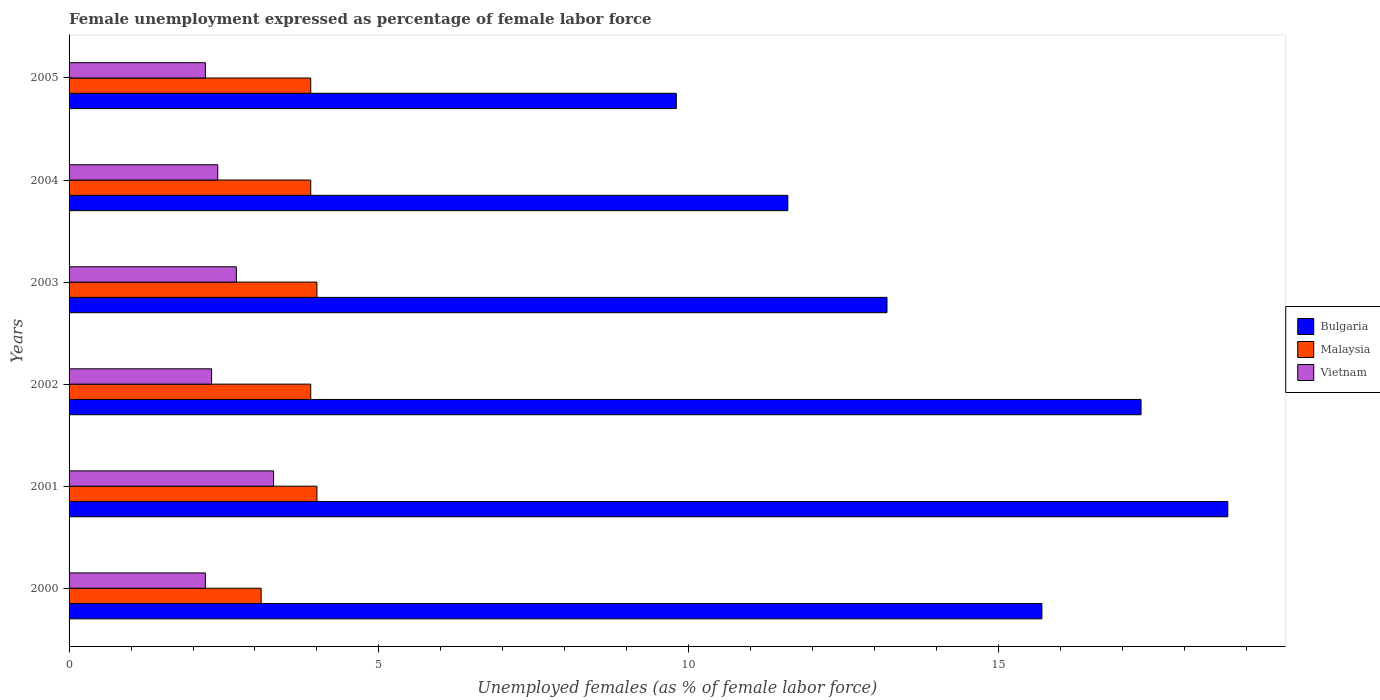How many different coloured bars are there?
Offer a terse response. 3. How many groups of bars are there?
Keep it short and to the point. 6. How many bars are there on the 4th tick from the top?
Provide a short and direct response. 3. What is the label of the 3rd group of bars from the top?
Provide a short and direct response. 2003. In how many cases, is the number of bars for a given year not equal to the number of legend labels?
Your answer should be compact. 0. Across all years, what is the maximum unemployment in females in in Bulgaria?
Your response must be concise. 18.7. Across all years, what is the minimum unemployment in females in in Malaysia?
Ensure brevity in your answer.  3.1. In which year was the unemployment in females in in Bulgaria maximum?
Make the answer very short. 2001. What is the total unemployment in females in in Malaysia in the graph?
Ensure brevity in your answer.  22.8. What is the difference between the unemployment in females in in Bulgaria in 2003 and that in 2004?
Provide a succinct answer. 1.6. What is the difference between the unemployment in females in in Vietnam in 2003 and the unemployment in females in in Malaysia in 2002?
Offer a terse response. -1.2. What is the average unemployment in females in in Malaysia per year?
Offer a terse response. 3.8. In the year 2005, what is the difference between the unemployment in females in in Malaysia and unemployment in females in in Bulgaria?
Give a very brief answer. -5.9. What is the ratio of the unemployment in females in in Malaysia in 2000 to that in 2002?
Your response must be concise. 0.79. Is the difference between the unemployment in females in in Malaysia in 2002 and 2003 greater than the difference between the unemployment in females in in Bulgaria in 2002 and 2003?
Your response must be concise. No. What is the difference between the highest and the second highest unemployment in females in in Bulgaria?
Ensure brevity in your answer.  1.4. What is the difference between the highest and the lowest unemployment in females in in Vietnam?
Your answer should be very brief. 1.1. In how many years, is the unemployment in females in in Malaysia greater than the average unemployment in females in in Malaysia taken over all years?
Offer a very short reply. 5. What does the 3rd bar from the top in 2003 represents?
Your answer should be compact. Bulgaria. What does the 2nd bar from the bottom in 2005 represents?
Offer a very short reply. Malaysia. Is it the case that in every year, the sum of the unemployment in females in in Bulgaria and unemployment in females in in Vietnam is greater than the unemployment in females in in Malaysia?
Your answer should be compact. Yes. Are all the bars in the graph horizontal?
Offer a terse response. Yes. How many years are there in the graph?
Your response must be concise. 6. What is the difference between two consecutive major ticks on the X-axis?
Provide a short and direct response. 5. Does the graph contain any zero values?
Make the answer very short. No. Where does the legend appear in the graph?
Offer a terse response. Center right. How are the legend labels stacked?
Give a very brief answer. Vertical. What is the title of the graph?
Give a very brief answer. Female unemployment expressed as percentage of female labor force. What is the label or title of the X-axis?
Your answer should be very brief. Unemployed females (as % of female labor force). What is the Unemployed females (as % of female labor force) in Bulgaria in 2000?
Give a very brief answer. 15.7. What is the Unemployed females (as % of female labor force) of Malaysia in 2000?
Your answer should be very brief. 3.1. What is the Unemployed females (as % of female labor force) of Vietnam in 2000?
Offer a terse response. 2.2. What is the Unemployed females (as % of female labor force) in Bulgaria in 2001?
Ensure brevity in your answer.  18.7. What is the Unemployed females (as % of female labor force) in Malaysia in 2001?
Keep it short and to the point. 4. What is the Unemployed females (as % of female labor force) of Vietnam in 2001?
Your answer should be compact. 3.3. What is the Unemployed females (as % of female labor force) of Bulgaria in 2002?
Make the answer very short. 17.3. What is the Unemployed females (as % of female labor force) in Malaysia in 2002?
Give a very brief answer. 3.9. What is the Unemployed females (as % of female labor force) of Vietnam in 2002?
Your answer should be compact. 2.3. What is the Unemployed females (as % of female labor force) in Bulgaria in 2003?
Keep it short and to the point. 13.2. What is the Unemployed females (as % of female labor force) of Vietnam in 2003?
Keep it short and to the point. 2.7. What is the Unemployed females (as % of female labor force) of Bulgaria in 2004?
Offer a terse response. 11.6. What is the Unemployed females (as % of female labor force) in Malaysia in 2004?
Your answer should be compact. 3.9. What is the Unemployed females (as % of female labor force) of Vietnam in 2004?
Give a very brief answer. 2.4. What is the Unemployed females (as % of female labor force) of Bulgaria in 2005?
Your answer should be compact. 9.8. What is the Unemployed females (as % of female labor force) of Malaysia in 2005?
Your answer should be compact. 3.9. What is the Unemployed females (as % of female labor force) in Vietnam in 2005?
Offer a very short reply. 2.2. Across all years, what is the maximum Unemployed females (as % of female labor force) in Bulgaria?
Your response must be concise. 18.7. Across all years, what is the maximum Unemployed females (as % of female labor force) of Vietnam?
Ensure brevity in your answer.  3.3. Across all years, what is the minimum Unemployed females (as % of female labor force) in Bulgaria?
Offer a terse response. 9.8. Across all years, what is the minimum Unemployed females (as % of female labor force) in Malaysia?
Keep it short and to the point. 3.1. Across all years, what is the minimum Unemployed females (as % of female labor force) of Vietnam?
Provide a short and direct response. 2.2. What is the total Unemployed females (as % of female labor force) of Bulgaria in the graph?
Your response must be concise. 86.3. What is the total Unemployed females (as % of female labor force) in Malaysia in the graph?
Make the answer very short. 22.8. What is the total Unemployed females (as % of female labor force) in Vietnam in the graph?
Give a very brief answer. 15.1. What is the difference between the Unemployed females (as % of female labor force) of Bulgaria in 2000 and that in 2001?
Ensure brevity in your answer.  -3. What is the difference between the Unemployed females (as % of female labor force) of Vietnam in 2000 and that in 2001?
Provide a succinct answer. -1.1. What is the difference between the Unemployed females (as % of female labor force) in Vietnam in 2000 and that in 2002?
Ensure brevity in your answer.  -0.1. What is the difference between the Unemployed females (as % of female labor force) in Malaysia in 2000 and that in 2003?
Your response must be concise. -0.9. What is the difference between the Unemployed females (as % of female labor force) in Vietnam in 2000 and that in 2003?
Offer a terse response. -0.5. What is the difference between the Unemployed females (as % of female labor force) of Vietnam in 2000 and that in 2004?
Provide a succinct answer. -0.2. What is the difference between the Unemployed females (as % of female labor force) in Bulgaria in 2000 and that in 2005?
Your answer should be very brief. 5.9. What is the difference between the Unemployed females (as % of female labor force) of Malaysia in 2000 and that in 2005?
Provide a short and direct response. -0.8. What is the difference between the Unemployed females (as % of female labor force) of Vietnam in 2000 and that in 2005?
Make the answer very short. 0. What is the difference between the Unemployed females (as % of female labor force) in Bulgaria in 2001 and that in 2002?
Offer a very short reply. 1.4. What is the difference between the Unemployed females (as % of female labor force) in Malaysia in 2001 and that in 2002?
Offer a terse response. 0.1. What is the difference between the Unemployed females (as % of female labor force) of Vietnam in 2001 and that in 2002?
Make the answer very short. 1. What is the difference between the Unemployed females (as % of female labor force) of Malaysia in 2001 and that in 2003?
Make the answer very short. 0. What is the difference between the Unemployed females (as % of female labor force) in Vietnam in 2001 and that in 2003?
Your response must be concise. 0.6. What is the difference between the Unemployed females (as % of female labor force) of Vietnam in 2001 and that in 2004?
Your response must be concise. 0.9. What is the difference between the Unemployed females (as % of female labor force) in Bulgaria in 2001 and that in 2005?
Provide a short and direct response. 8.9. What is the difference between the Unemployed females (as % of female labor force) in Malaysia in 2001 and that in 2005?
Your answer should be very brief. 0.1. What is the difference between the Unemployed females (as % of female labor force) in Vietnam in 2001 and that in 2005?
Your answer should be compact. 1.1. What is the difference between the Unemployed females (as % of female labor force) in Malaysia in 2002 and that in 2003?
Give a very brief answer. -0.1. What is the difference between the Unemployed females (as % of female labor force) of Vietnam in 2002 and that in 2003?
Ensure brevity in your answer.  -0.4. What is the difference between the Unemployed females (as % of female labor force) in Bulgaria in 2002 and that in 2004?
Give a very brief answer. 5.7. What is the difference between the Unemployed females (as % of female labor force) in Malaysia in 2002 and that in 2004?
Keep it short and to the point. 0. What is the difference between the Unemployed females (as % of female labor force) of Vietnam in 2002 and that in 2004?
Ensure brevity in your answer.  -0.1. What is the difference between the Unemployed females (as % of female labor force) in Vietnam in 2003 and that in 2004?
Ensure brevity in your answer.  0.3. What is the difference between the Unemployed females (as % of female labor force) of Malaysia in 2003 and that in 2005?
Provide a succinct answer. 0.1. What is the difference between the Unemployed females (as % of female labor force) in Vietnam in 2003 and that in 2005?
Provide a succinct answer. 0.5. What is the difference between the Unemployed females (as % of female labor force) in Malaysia in 2004 and that in 2005?
Offer a very short reply. 0. What is the difference between the Unemployed females (as % of female labor force) in Vietnam in 2004 and that in 2005?
Provide a succinct answer. 0.2. What is the difference between the Unemployed females (as % of female labor force) in Bulgaria in 2000 and the Unemployed females (as % of female labor force) in Vietnam in 2001?
Offer a terse response. 12.4. What is the difference between the Unemployed females (as % of female labor force) of Bulgaria in 2000 and the Unemployed females (as % of female labor force) of Malaysia in 2002?
Your answer should be very brief. 11.8. What is the difference between the Unemployed females (as % of female labor force) of Bulgaria in 2000 and the Unemployed females (as % of female labor force) of Vietnam in 2002?
Your answer should be very brief. 13.4. What is the difference between the Unemployed females (as % of female labor force) in Malaysia in 2000 and the Unemployed females (as % of female labor force) in Vietnam in 2002?
Give a very brief answer. 0.8. What is the difference between the Unemployed females (as % of female labor force) of Bulgaria in 2000 and the Unemployed females (as % of female labor force) of Vietnam in 2003?
Your answer should be compact. 13. What is the difference between the Unemployed females (as % of female labor force) of Malaysia in 2000 and the Unemployed females (as % of female labor force) of Vietnam in 2003?
Keep it short and to the point. 0.4. What is the difference between the Unemployed females (as % of female labor force) in Bulgaria in 2000 and the Unemployed females (as % of female labor force) in Malaysia in 2004?
Your answer should be very brief. 11.8. What is the difference between the Unemployed females (as % of female labor force) in Bulgaria in 2000 and the Unemployed females (as % of female labor force) in Vietnam in 2004?
Your answer should be compact. 13.3. What is the difference between the Unemployed females (as % of female labor force) in Malaysia in 2000 and the Unemployed females (as % of female labor force) in Vietnam in 2004?
Make the answer very short. 0.7. What is the difference between the Unemployed females (as % of female labor force) in Malaysia in 2000 and the Unemployed females (as % of female labor force) in Vietnam in 2005?
Your answer should be very brief. 0.9. What is the difference between the Unemployed females (as % of female labor force) of Bulgaria in 2001 and the Unemployed females (as % of female labor force) of Vietnam in 2002?
Offer a terse response. 16.4. What is the difference between the Unemployed females (as % of female labor force) of Malaysia in 2001 and the Unemployed females (as % of female labor force) of Vietnam in 2002?
Offer a terse response. 1.7. What is the difference between the Unemployed females (as % of female labor force) in Bulgaria in 2001 and the Unemployed females (as % of female labor force) in Malaysia in 2003?
Your answer should be compact. 14.7. What is the difference between the Unemployed females (as % of female labor force) of Malaysia in 2001 and the Unemployed females (as % of female labor force) of Vietnam in 2003?
Your answer should be very brief. 1.3. What is the difference between the Unemployed females (as % of female labor force) of Bulgaria in 2001 and the Unemployed females (as % of female labor force) of Vietnam in 2004?
Offer a terse response. 16.3. What is the difference between the Unemployed females (as % of female labor force) in Bulgaria in 2001 and the Unemployed females (as % of female labor force) in Vietnam in 2005?
Your answer should be compact. 16.5. What is the difference between the Unemployed females (as % of female labor force) of Malaysia in 2002 and the Unemployed females (as % of female labor force) of Vietnam in 2003?
Ensure brevity in your answer.  1.2. What is the difference between the Unemployed females (as % of female labor force) in Bulgaria in 2002 and the Unemployed females (as % of female labor force) in Vietnam in 2004?
Keep it short and to the point. 14.9. What is the difference between the Unemployed females (as % of female labor force) in Malaysia in 2002 and the Unemployed females (as % of female labor force) in Vietnam in 2004?
Provide a short and direct response. 1.5. What is the difference between the Unemployed females (as % of female labor force) in Bulgaria in 2002 and the Unemployed females (as % of female labor force) in Malaysia in 2005?
Your answer should be very brief. 13.4. What is the difference between the Unemployed females (as % of female labor force) in Bulgaria in 2003 and the Unemployed females (as % of female labor force) in Malaysia in 2004?
Make the answer very short. 9.3. What is the difference between the Unemployed females (as % of female labor force) in Malaysia in 2003 and the Unemployed females (as % of female labor force) in Vietnam in 2004?
Offer a very short reply. 1.6. What is the difference between the Unemployed females (as % of female labor force) of Bulgaria in 2003 and the Unemployed females (as % of female labor force) of Vietnam in 2005?
Offer a terse response. 11. What is the difference between the Unemployed females (as % of female labor force) in Malaysia in 2003 and the Unemployed females (as % of female labor force) in Vietnam in 2005?
Your answer should be compact. 1.8. What is the difference between the Unemployed females (as % of female labor force) of Bulgaria in 2004 and the Unemployed females (as % of female labor force) of Vietnam in 2005?
Your answer should be very brief. 9.4. What is the average Unemployed females (as % of female labor force) in Bulgaria per year?
Provide a short and direct response. 14.38. What is the average Unemployed females (as % of female labor force) in Malaysia per year?
Provide a short and direct response. 3.8. What is the average Unemployed females (as % of female labor force) in Vietnam per year?
Provide a succinct answer. 2.52. In the year 2000, what is the difference between the Unemployed females (as % of female labor force) of Bulgaria and Unemployed females (as % of female labor force) of Malaysia?
Offer a very short reply. 12.6. In the year 2000, what is the difference between the Unemployed females (as % of female labor force) of Bulgaria and Unemployed females (as % of female labor force) of Vietnam?
Keep it short and to the point. 13.5. In the year 2001, what is the difference between the Unemployed females (as % of female labor force) of Bulgaria and Unemployed females (as % of female labor force) of Vietnam?
Your answer should be very brief. 15.4. In the year 2001, what is the difference between the Unemployed females (as % of female labor force) of Malaysia and Unemployed females (as % of female labor force) of Vietnam?
Your response must be concise. 0.7. In the year 2002, what is the difference between the Unemployed females (as % of female labor force) of Bulgaria and Unemployed females (as % of female labor force) of Vietnam?
Your answer should be compact. 15. In the year 2002, what is the difference between the Unemployed females (as % of female labor force) in Malaysia and Unemployed females (as % of female labor force) in Vietnam?
Your answer should be very brief. 1.6. In the year 2003, what is the difference between the Unemployed females (as % of female labor force) in Bulgaria and Unemployed females (as % of female labor force) in Vietnam?
Ensure brevity in your answer.  10.5. In the year 2003, what is the difference between the Unemployed females (as % of female labor force) of Malaysia and Unemployed females (as % of female labor force) of Vietnam?
Keep it short and to the point. 1.3. In the year 2004, what is the difference between the Unemployed females (as % of female labor force) in Bulgaria and Unemployed females (as % of female labor force) in Malaysia?
Your response must be concise. 7.7. In the year 2004, what is the difference between the Unemployed females (as % of female labor force) in Malaysia and Unemployed females (as % of female labor force) in Vietnam?
Provide a succinct answer. 1.5. In the year 2005, what is the difference between the Unemployed females (as % of female labor force) of Malaysia and Unemployed females (as % of female labor force) of Vietnam?
Give a very brief answer. 1.7. What is the ratio of the Unemployed females (as % of female labor force) in Bulgaria in 2000 to that in 2001?
Ensure brevity in your answer.  0.84. What is the ratio of the Unemployed females (as % of female labor force) of Malaysia in 2000 to that in 2001?
Provide a short and direct response. 0.78. What is the ratio of the Unemployed females (as % of female labor force) in Vietnam in 2000 to that in 2001?
Offer a very short reply. 0.67. What is the ratio of the Unemployed females (as % of female labor force) of Bulgaria in 2000 to that in 2002?
Offer a terse response. 0.91. What is the ratio of the Unemployed females (as % of female labor force) in Malaysia in 2000 to that in 2002?
Offer a very short reply. 0.79. What is the ratio of the Unemployed females (as % of female labor force) of Vietnam in 2000 to that in 2002?
Give a very brief answer. 0.96. What is the ratio of the Unemployed females (as % of female labor force) in Bulgaria in 2000 to that in 2003?
Provide a succinct answer. 1.19. What is the ratio of the Unemployed females (as % of female labor force) of Malaysia in 2000 to that in 2003?
Offer a terse response. 0.78. What is the ratio of the Unemployed females (as % of female labor force) of Vietnam in 2000 to that in 2003?
Offer a terse response. 0.81. What is the ratio of the Unemployed females (as % of female labor force) in Bulgaria in 2000 to that in 2004?
Keep it short and to the point. 1.35. What is the ratio of the Unemployed females (as % of female labor force) of Malaysia in 2000 to that in 2004?
Offer a very short reply. 0.79. What is the ratio of the Unemployed females (as % of female labor force) of Bulgaria in 2000 to that in 2005?
Keep it short and to the point. 1.6. What is the ratio of the Unemployed females (as % of female labor force) of Malaysia in 2000 to that in 2005?
Provide a short and direct response. 0.79. What is the ratio of the Unemployed females (as % of female labor force) of Bulgaria in 2001 to that in 2002?
Your answer should be very brief. 1.08. What is the ratio of the Unemployed females (as % of female labor force) in Malaysia in 2001 to that in 2002?
Provide a succinct answer. 1.03. What is the ratio of the Unemployed females (as % of female labor force) of Vietnam in 2001 to that in 2002?
Make the answer very short. 1.43. What is the ratio of the Unemployed females (as % of female labor force) in Bulgaria in 2001 to that in 2003?
Make the answer very short. 1.42. What is the ratio of the Unemployed females (as % of female labor force) in Vietnam in 2001 to that in 2003?
Offer a very short reply. 1.22. What is the ratio of the Unemployed females (as % of female labor force) in Bulgaria in 2001 to that in 2004?
Your answer should be very brief. 1.61. What is the ratio of the Unemployed females (as % of female labor force) in Malaysia in 2001 to that in 2004?
Provide a succinct answer. 1.03. What is the ratio of the Unemployed females (as % of female labor force) in Vietnam in 2001 to that in 2004?
Offer a terse response. 1.38. What is the ratio of the Unemployed females (as % of female labor force) of Bulgaria in 2001 to that in 2005?
Keep it short and to the point. 1.91. What is the ratio of the Unemployed females (as % of female labor force) in Malaysia in 2001 to that in 2005?
Offer a terse response. 1.03. What is the ratio of the Unemployed females (as % of female labor force) of Vietnam in 2001 to that in 2005?
Ensure brevity in your answer.  1.5. What is the ratio of the Unemployed females (as % of female labor force) in Bulgaria in 2002 to that in 2003?
Ensure brevity in your answer.  1.31. What is the ratio of the Unemployed females (as % of female labor force) in Vietnam in 2002 to that in 2003?
Make the answer very short. 0.85. What is the ratio of the Unemployed females (as % of female labor force) in Bulgaria in 2002 to that in 2004?
Keep it short and to the point. 1.49. What is the ratio of the Unemployed females (as % of female labor force) of Malaysia in 2002 to that in 2004?
Your answer should be very brief. 1. What is the ratio of the Unemployed females (as % of female labor force) of Vietnam in 2002 to that in 2004?
Offer a very short reply. 0.96. What is the ratio of the Unemployed females (as % of female labor force) of Bulgaria in 2002 to that in 2005?
Make the answer very short. 1.77. What is the ratio of the Unemployed females (as % of female labor force) of Vietnam in 2002 to that in 2005?
Your answer should be very brief. 1.05. What is the ratio of the Unemployed females (as % of female labor force) of Bulgaria in 2003 to that in 2004?
Your response must be concise. 1.14. What is the ratio of the Unemployed females (as % of female labor force) of Malaysia in 2003 to that in 2004?
Your answer should be very brief. 1.03. What is the ratio of the Unemployed females (as % of female labor force) of Vietnam in 2003 to that in 2004?
Your answer should be compact. 1.12. What is the ratio of the Unemployed females (as % of female labor force) in Bulgaria in 2003 to that in 2005?
Make the answer very short. 1.35. What is the ratio of the Unemployed females (as % of female labor force) in Malaysia in 2003 to that in 2005?
Your response must be concise. 1.03. What is the ratio of the Unemployed females (as % of female labor force) of Vietnam in 2003 to that in 2005?
Your answer should be compact. 1.23. What is the ratio of the Unemployed females (as % of female labor force) of Bulgaria in 2004 to that in 2005?
Ensure brevity in your answer.  1.18. What is the ratio of the Unemployed females (as % of female labor force) of Malaysia in 2004 to that in 2005?
Provide a succinct answer. 1. What is the difference between the highest and the lowest Unemployed females (as % of female labor force) in Malaysia?
Offer a terse response. 0.9. What is the difference between the highest and the lowest Unemployed females (as % of female labor force) in Vietnam?
Offer a very short reply. 1.1. 